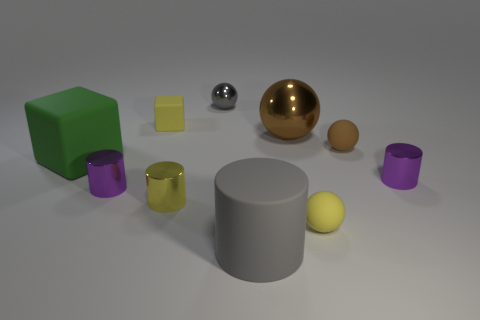There is a small block; is its color the same as the cylinder that is in front of the small yellow shiny cylinder?
Your answer should be compact. No. The tiny cylinder that is both behind the small yellow cylinder and on the right side of the yellow rubber cube is what color?
Provide a succinct answer. Purple. What number of other things are made of the same material as the large green object?
Your response must be concise. 4. Is the number of small spheres less than the number of large matte cylinders?
Keep it short and to the point. No. Do the big gray cylinder and the purple thing that is to the left of the gray cylinder have the same material?
Offer a terse response. No. There is a small rubber object that is behind the brown rubber object; what is its shape?
Offer a very short reply. Cube. Is there any other thing of the same color as the big shiny sphere?
Offer a very short reply. Yes. Are there fewer metal things that are left of the gray sphere than purple metallic cylinders?
Provide a succinct answer. No. How many yellow cubes have the same size as the gray sphere?
Offer a very short reply. 1. The tiny metallic object that is the same color as the small matte cube is what shape?
Give a very brief answer. Cylinder. 